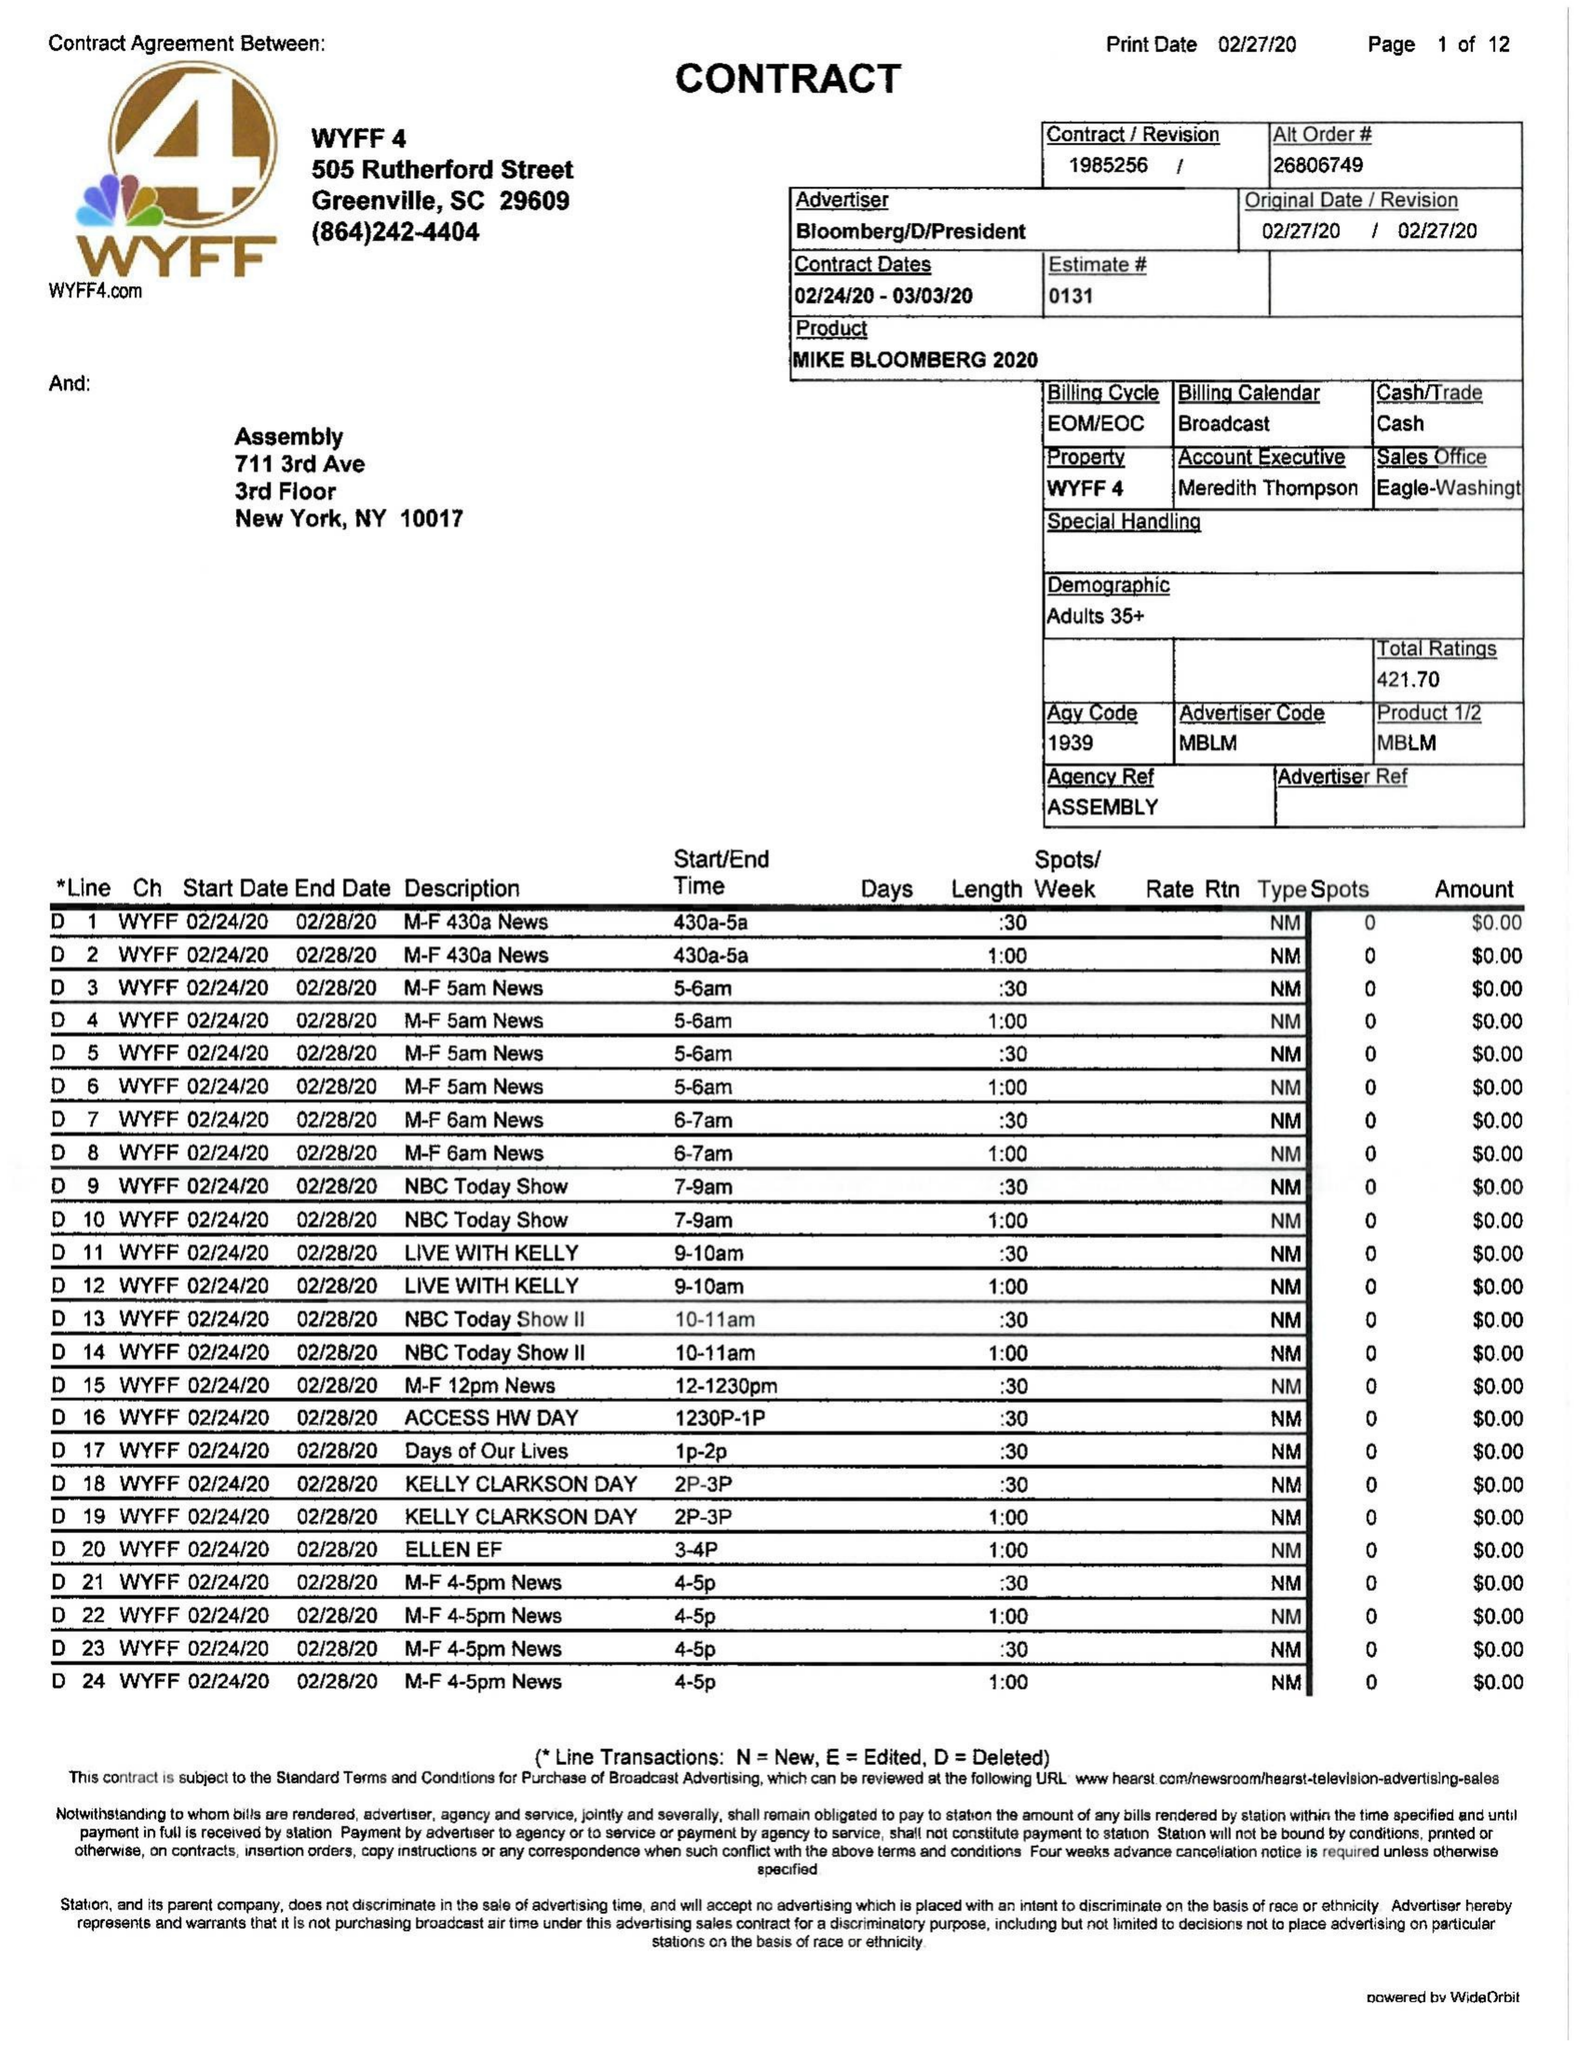What is the value for the flight_from?
Answer the question using a single word or phrase. 02/24/20 